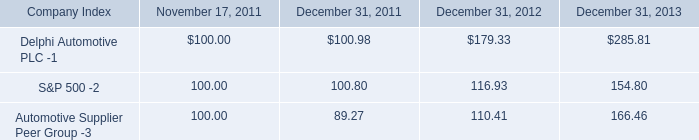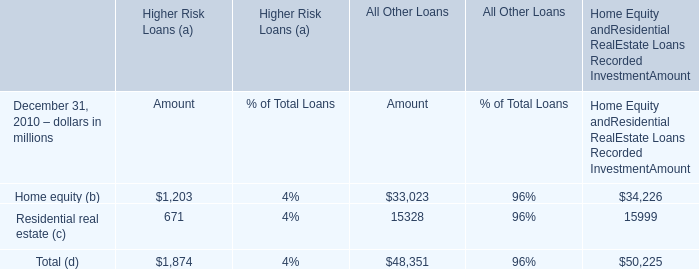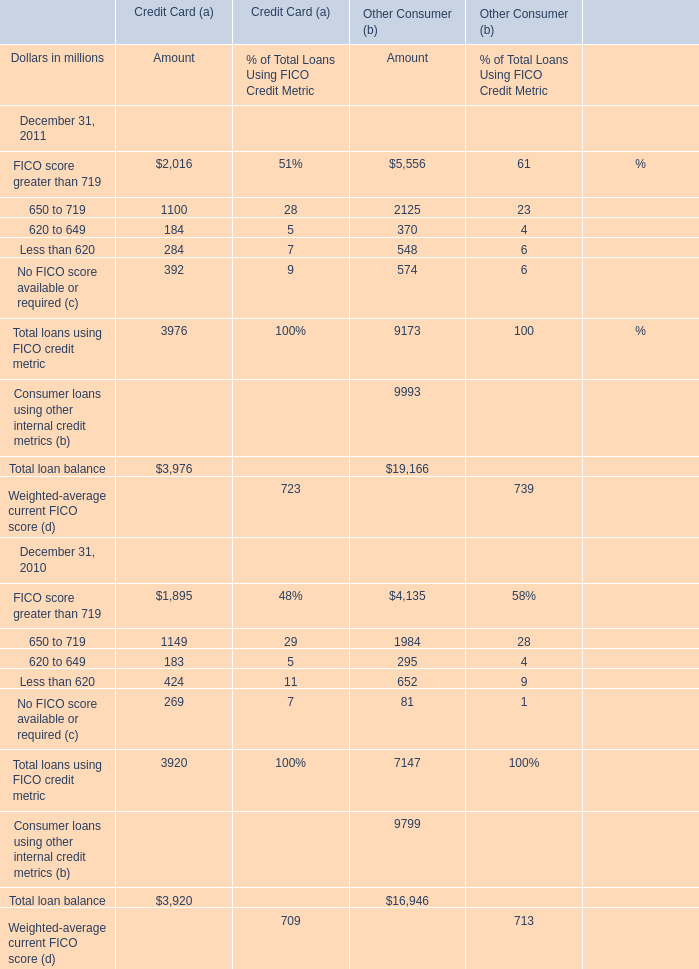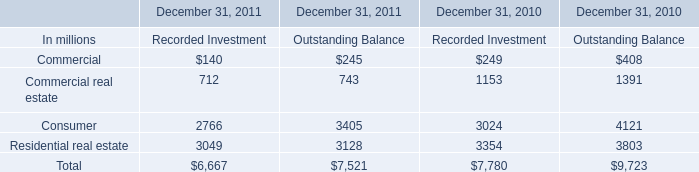What is the sum of elements for Home Equity andResidential RealEstate Loans Recorded InvestmentAmount? (in million) 
Computations: (34226 + 15999)
Answer: 50225.0. 